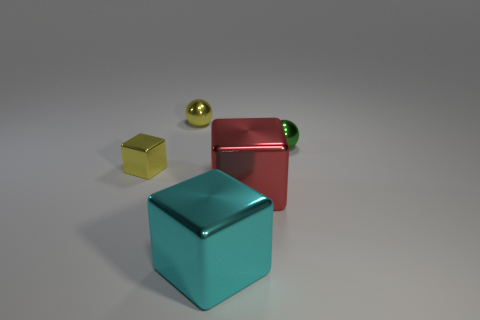How many things are tiny green things or large gray shiny spheres?
Provide a succinct answer. 1. The big metallic object to the left of the big red thing has what shape?
Keep it short and to the point. Cube. The other sphere that is made of the same material as the yellow sphere is what color?
Keep it short and to the point. Green. What material is the tiny yellow thing that is the same shape as the green object?
Ensure brevity in your answer.  Metal. The green object is what shape?
Keep it short and to the point. Sphere. What is the cube that is both on the left side of the large red metal block and in front of the tiny block made of?
Give a very brief answer. Metal. There is a yellow object that is made of the same material as the yellow sphere; what is its shape?
Provide a succinct answer. Cube. There is a yellow ball that is made of the same material as the cyan thing; what size is it?
Your answer should be compact. Small. There is a object that is both behind the tiny block and to the left of the red block; what shape is it?
Offer a terse response. Sphere. What size is the object that is left of the tiny yellow shiny thing that is behind the yellow metal block?
Offer a very short reply. Small. 